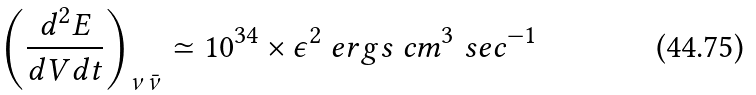<formula> <loc_0><loc_0><loc_500><loc_500>\left ( { \frac { d ^ { 2 } E } { d V d t } } \right ) _ { \nu \bar { \nu } } \simeq 1 0 ^ { 3 4 } \times \epsilon ^ { 2 } \ e r g s \ c m ^ { 3 } \ s e c ^ { - 1 }</formula> 